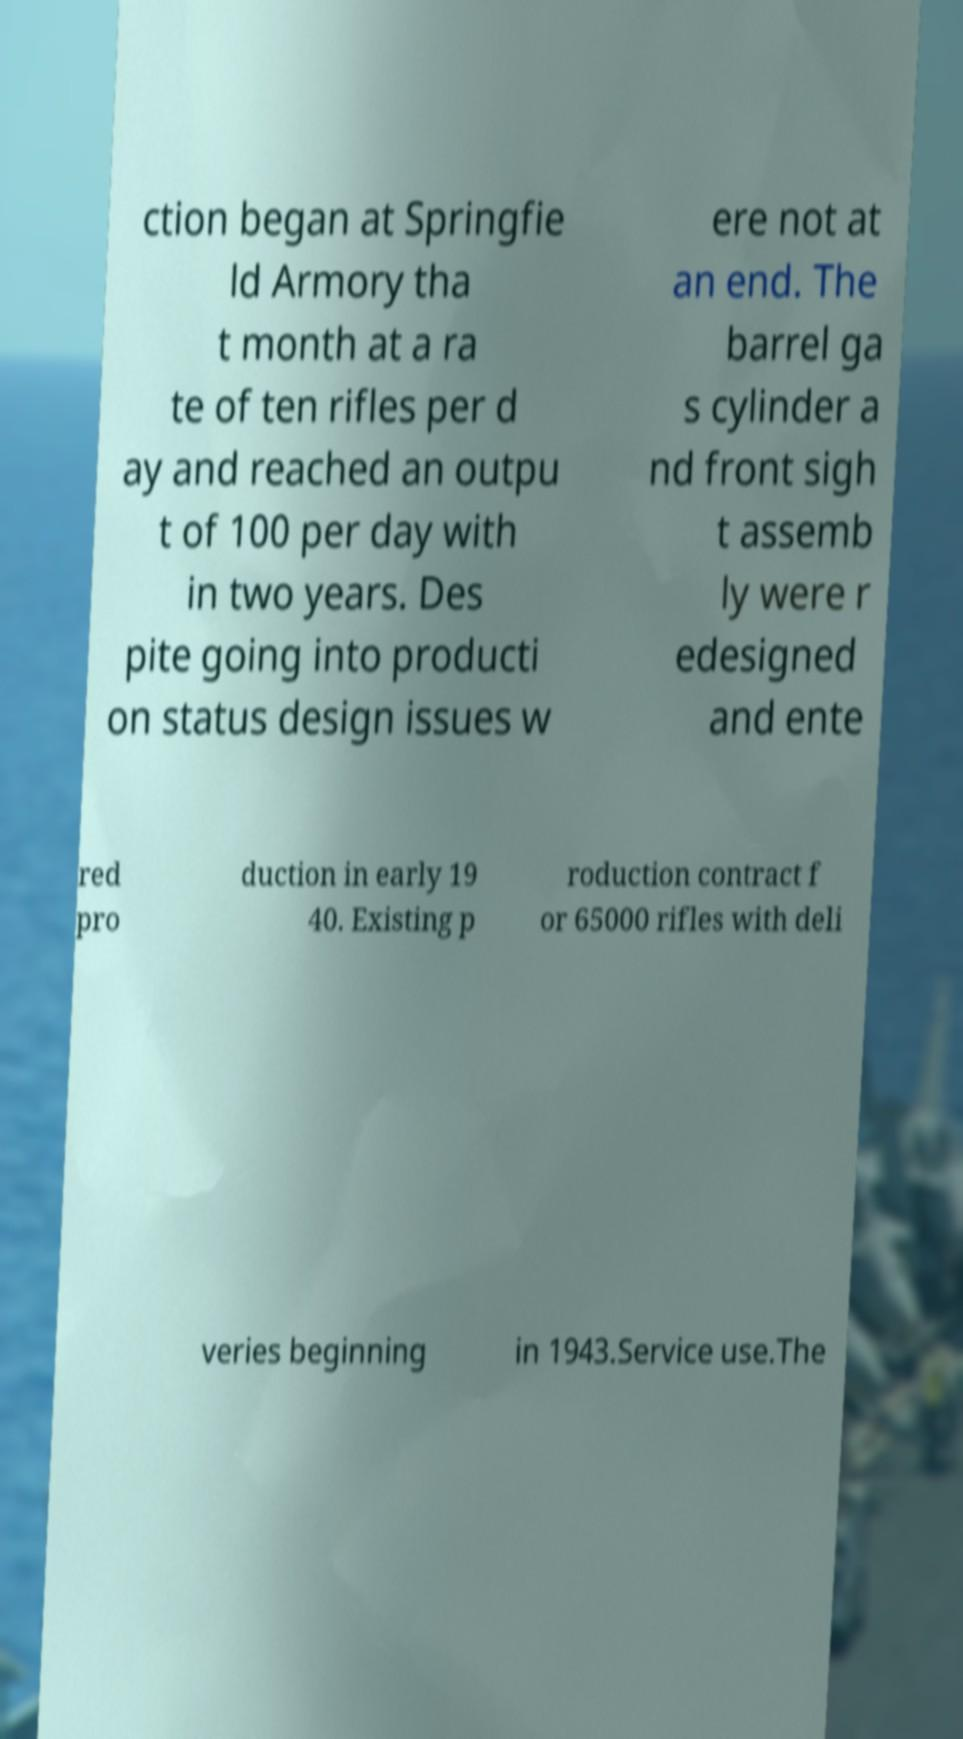Please read and relay the text visible in this image. What does it say? ction began at Springfie ld Armory tha t month at a ra te of ten rifles per d ay and reached an outpu t of 100 per day with in two years. Des pite going into producti on status design issues w ere not at an end. The barrel ga s cylinder a nd front sigh t assemb ly were r edesigned and ente red pro duction in early 19 40. Existing p roduction contract f or 65000 rifles with deli veries beginning in 1943.Service use.The 